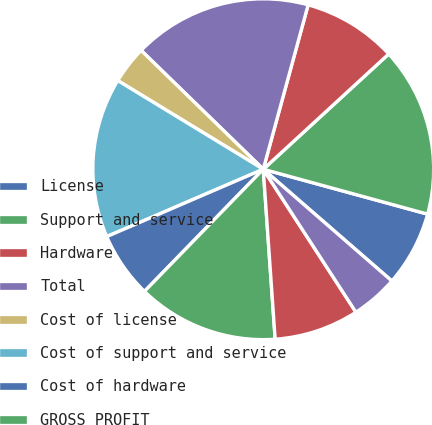<chart> <loc_0><loc_0><loc_500><loc_500><pie_chart><fcel>License<fcel>Support and service<fcel>Hardware<fcel>Total<fcel>Cost of license<fcel>Cost of support and service<fcel>Cost of hardware<fcel>GROSS PROFIT<fcel>Selling and marketing<fcel>Research and development<nl><fcel>7.14%<fcel>16.07%<fcel>8.93%<fcel>16.96%<fcel>3.57%<fcel>15.18%<fcel>6.25%<fcel>13.39%<fcel>8.04%<fcel>4.46%<nl></chart> 